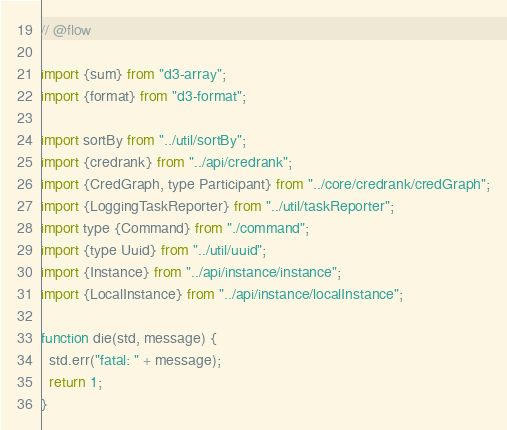Convert code to text. <code><loc_0><loc_0><loc_500><loc_500><_JavaScript_>// @flow

import {sum} from "d3-array";
import {format} from "d3-format";

import sortBy from "../util/sortBy";
import {credrank} from "../api/credrank";
import {CredGraph, type Participant} from "../core/credrank/credGraph";
import {LoggingTaskReporter} from "../util/taskReporter";
import type {Command} from "./command";
import {type Uuid} from "../util/uuid";
import {Instance} from "../api/instance/instance";
import {LocalInstance} from "../api/instance/localInstance";

function die(std, message) {
  std.err("fatal: " + message);
  return 1;
}
</code> 